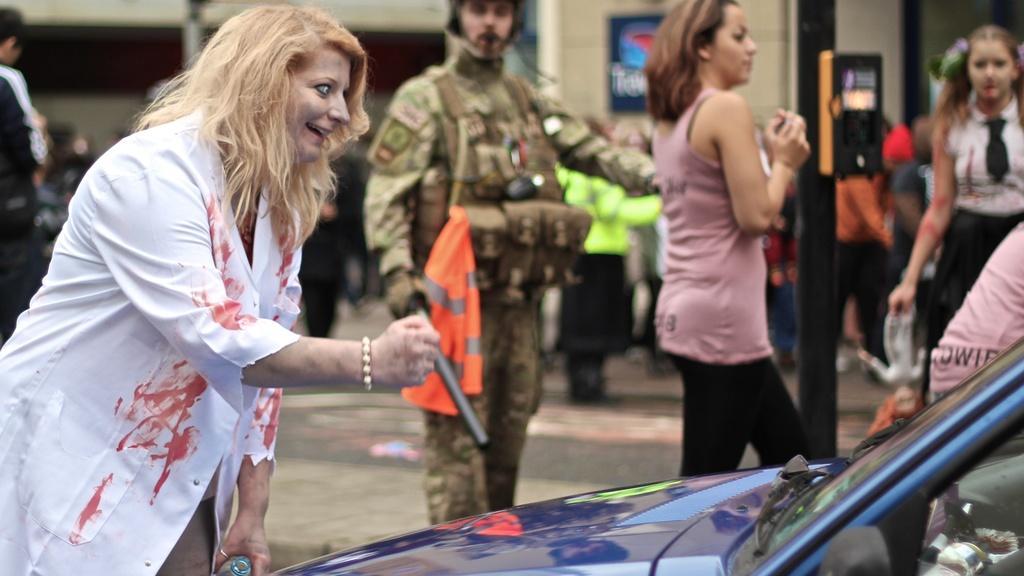Describe this image in one or two sentences. In this image I can see group of people are standing among them this man is wearing a uniform. Here I can see a vehicle. In the background I can see some object attached to a pole. The background of the image is blurred. 